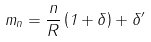Convert formula to latex. <formula><loc_0><loc_0><loc_500><loc_500>m _ { n } = \frac { n } { R } \left ( 1 + \delta \right ) + \delta ^ { \prime }</formula> 